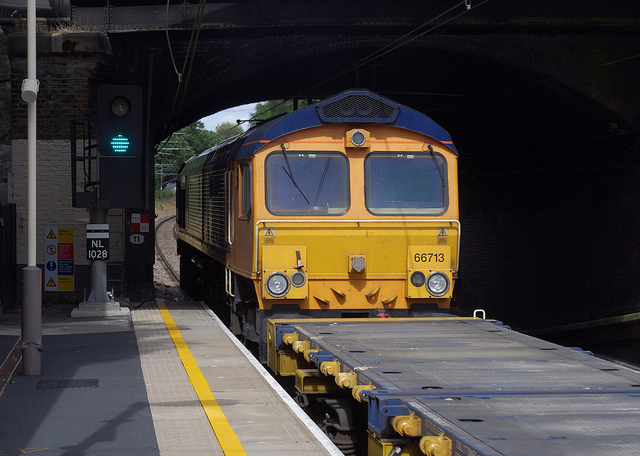Read and extract the text from this image. 66713 NL 1028 11 